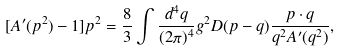<formula> <loc_0><loc_0><loc_500><loc_500>[ A ^ { \prime } ( p ^ { 2 } ) - 1 ] p ^ { 2 } = \frac { 8 } { 3 } \int \frac { d ^ { 4 } q } { ( 2 \pi ) ^ { 4 } } g ^ { 2 } D ( p - q ) \frac { p \cdot q } { q ^ { 2 } A ^ { \prime } ( q ^ { 2 } ) } ,</formula> 